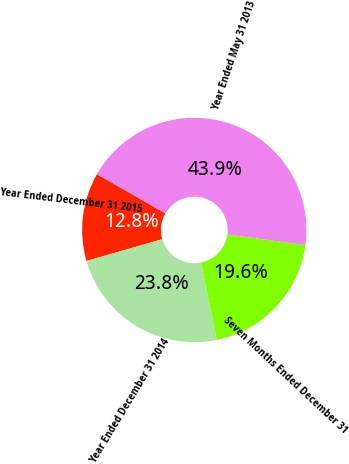<chart> <loc_0><loc_0><loc_500><loc_500><pie_chart><fcel>Year Ended December 31 2015<fcel>Year Ended December 31 2014<fcel>Seven Months Ended December 31<fcel>Year Ended May 31 2013<nl><fcel>12.75%<fcel>23.76%<fcel>19.63%<fcel>43.86%<nl></chart> 